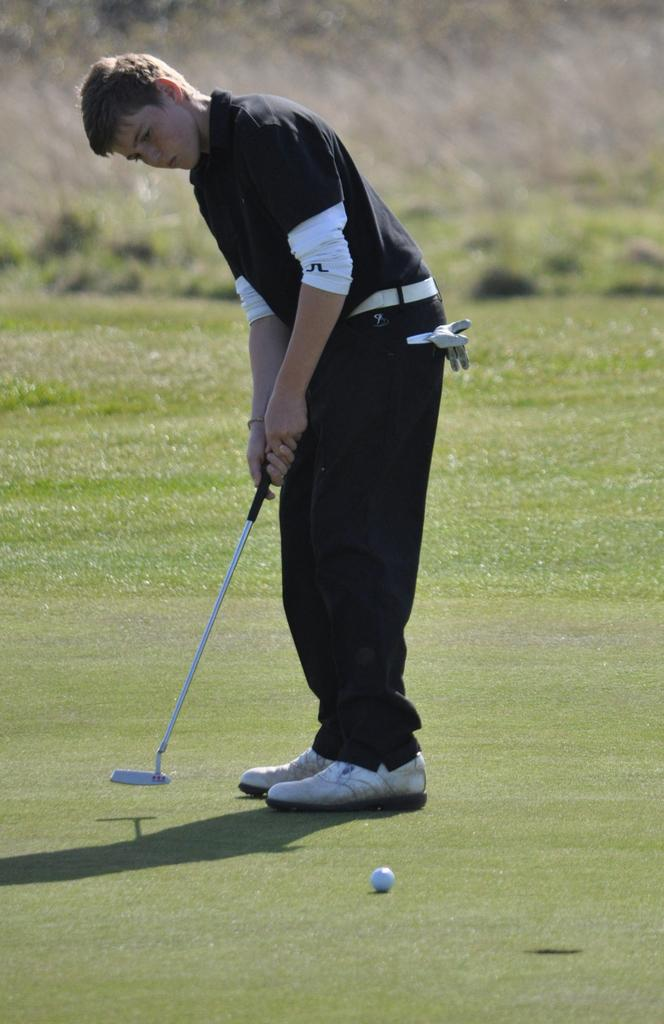What is the person in the image doing? The person is standing in the image and holding a golf bat. What object is at the bottom of the image? There is a ball at the bottom of the image. What type of cream is being used to push the ball in the image? There is no cream or pushing action present in the image; the person is simply holding a golf bat. 